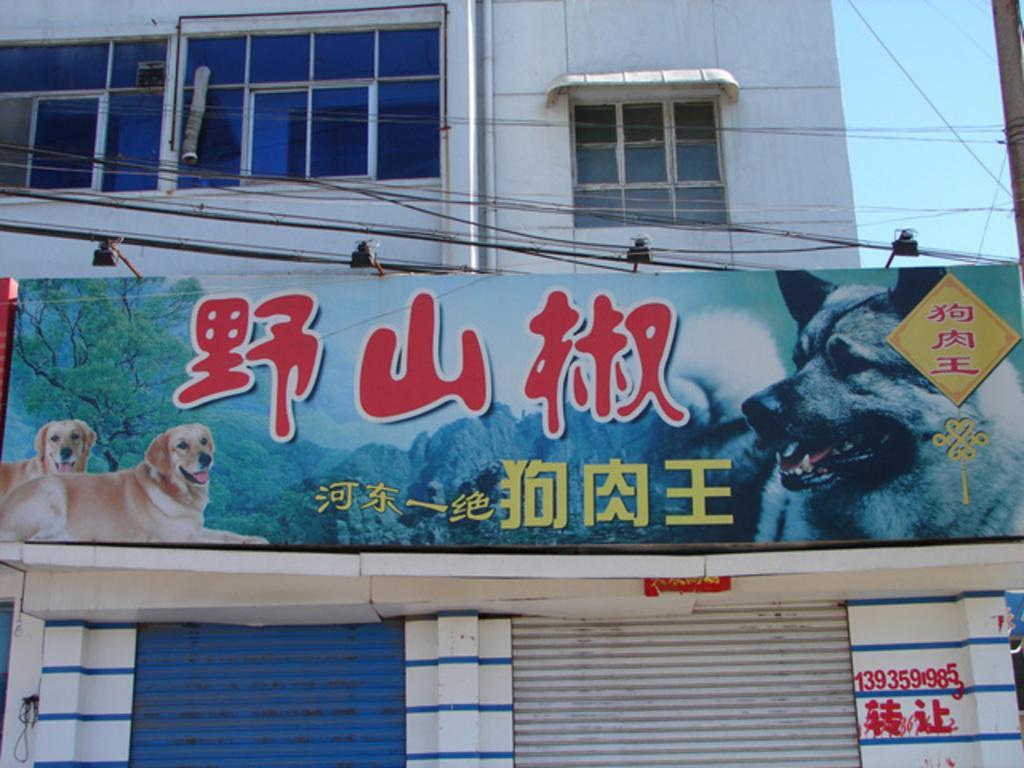Please provide a concise description of this image. In this image I can see the board to the building. I can also see the windows to the building. To the right I can see the pole and the sky. 